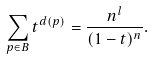<formula> <loc_0><loc_0><loc_500><loc_500>\sum _ { p \in B } t ^ { d ( p ) } = \frac { n ^ { l } } { ( 1 - t ) ^ { n } } .</formula> 